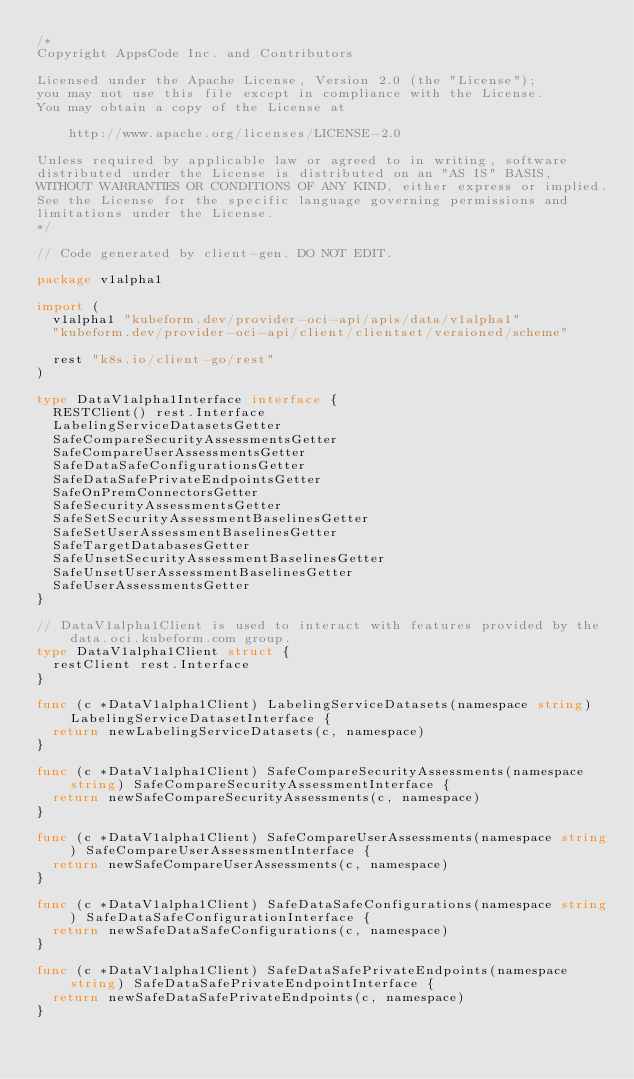Convert code to text. <code><loc_0><loc_0><loc_500><loc_500><_Go_>/*
Copyright AppsCode Inc. and Contributors

Licensed under the Apache License, Version 2.0 (the "License");
you may not use this file except in compliance with the License.
You may obtain a copy of the License at

    http://www.apache.org/licenses/LICENSE-2.0

Unless required by applicable law or agreed to in writing, software
distributed under the License is distributed on an "AS IS" BASIS,
WITHOUT WARRANTIES OR CONDITIONS OF ANY KIND, either express or implied.
See the License for the specific language governing permissions and
limitations under the License.
*/

// Code generated by client-gen. DO NOT EDIT.

package v1alpha1

import (
	v1alpha1 "kubeform.dev/provider-oci-api/apis/data/v1alpha1"
	"kubeform.dev/provider-oci-api/client/clientset/versioned/scheme"

	rest "k8s.io/client-go/rest"
)

type DataV1alpha1Interface interface {
	RESTClient() rest.Interface
	LabelingServiceDatasetsGetter
	SafeCompareSecurityAssessmentsGetter
	SafeCompareUserAssessmentsGetter
	SafeDataSafeConfigurationsGetter
	SafeDataSafePrivateEndpointsGetter
	SafeOnPremConnectorsGetter
	SafeSecurityAssessmentsGetter
	SafeSetSecurityAssessmentBaselinesGetter
	SafeSetUserAssessmentBaselinesGetter
	SafeTargetDatabasesGetter
	SafeUnsetSecurityAssessmentBaselinesGetter
	SafeUnsetUserAssessmentBaselinesGetter
	SafeUserAssessmentsGetter
}

// DataV1alpha1Client is used to interact with features provided by the data.oci.kubeform.com group.
type DataV1alpha1Client struct {
	restClient rest.Interface
}

func (c *DataV1alpha1Client) LabelingServiceDatasets(namespace string) LabelingServiceDatasetInterface {
	return newLabelingServiceDatasets(c, namespace)
}

func (c *DataV1alpha1Client) SafeCompareSecurityAssessments(namespace string) SafeCompareSecurityAssessmentInterface {
	return newSafeCompareSecurityAssessments(c, namespace)
}

func (c *DataV1alpha1Client) SafeCompareUserAssessments(namespace string) SafeCompareUserAssessmentInterface {
	return newSafeCompareUserAssessments(c, namespace)
}

func (c *DataV1alpha1Client) SafeDataSafeConfigurations(namespace string) SafeDataSafeConfigurationInterface {
	return newSafeDataSafeConfigurations(c, namespace)
}

func (c *DataV1alpha1Client) SafeDataSafePrivateEndpoints(namespace string) SafeDataSafePrivateEndpointInterface {
	return newSafeDataSafePrivateEndpoints(c, namespace)
}
</code> 